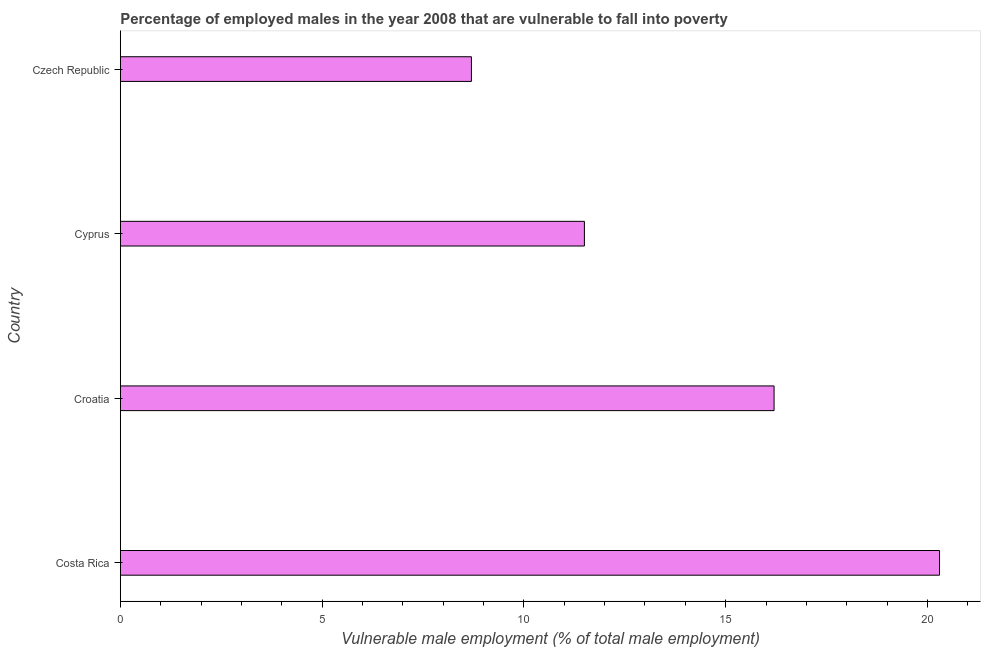What is the title of the graph?
Your response must be concise. Percentage of employed males in the year 2008 that are vulnerable to fall into poverty. What is the label or title of the X-axis?
Your answer should be compact. Vulnerable male employment (% of total male employment). What is the percentage of employed males who are vulnerable to fall into poverty in Cyprus?
Your answer should be compact. 11.5. Across all countries, what is the maximum percentage of employed males who are vulnerable to fall into poverty?
Your response must be concise. 20.3. Across all countries, what is the minimum percentage of employed males who are vulnerable to fall into poverty?
Keep it short and to the point. 8.7. In which country was the percentage of employed males who are vulnerable to fall into poverty maximum?
Give a very brief answer. Costa Rica. In which country was the percentage of employed males who are vulnerable to fall into poverty minimum?
Provide a short and direct response. Czech Republic. What is the sum of the percentage of employed males who are vulnerable to fall into poverty?
Offer a very short reply. 56.7. What is the difference between the percentage of employed males who are vulnerable to fall into poverty in Costa Rica and Croatia?
Give a very brief answer. 4.1. What is the average percentage of employed males who are vulnerable to fall into poverty per country?
Provide a short and direct response. 14.18. What is the median percentage of employed males who are vulnerable to fall into poverty?
Offer a very short reply. 13.85. What is the ratio of the percentage of employed males who are vulnerable to fall into poverty in Costa Rica to that in Czech Republic?
Offer a terse response. 2.33. Is the difference between the percentage of employed males who are vulnerable to fall into poverty in Costa Rica and Cyprus greater than the difference between any two countries?
Make the answer very short. No. What is the difference between the highest and the lowest percentage of employed males who are vulnerable to fall into poverty?
Your answer should be compact. 11.6. How many bars are there?
Your response must be concise. 4. How many countries are there in the graph?
Offer a terse response. 4. What is the Vulnerable male employment (% of total male employment) of Costa Rica?
Keep it short and to the point. 20.3. What is the Vulnerable male employment (% of total male employment) of Croatia?
Your answer should be compact. 16.2. What is the Vulnerable male employment (% of total male employment) of Cyprus?
Give a very brief answer. 11.5. What is the Vulnerable male employment (% of total male employment) of Czech Republic?
Offer a very short reply. 8.7. What is the ratio of the Vulnerable male employment (% of total male employment) in Costa Rica to that in Croatia?
Give a very brief answer. 1.25. What is the ratio of the Vulnerable male employment (% of total male employment) in Costa Rica to that in Cyprus?
Offer a very short reply. 1.76. What is the ratio of the Vulnerable male employment (% of total male employment) in Costa Rica to that in Czech Republic?
Offer a very short reply. 2.33. What is the ratio of the Vulnerable male employment (% of total male employment) in Croatia to that in Cyprus?
Provide a succinct answer. 1.41. What is the ratio of the Vulnerable male employment (% of total male employment) in Croatia to that in Czech Republic?
Your answer should be very brief. 1.86. What is the ratio of the Vulnerable male employment (% of total male employment) in Cyprus to that in Czech Republic?
Ensure brevity in your answer.  1.32. 